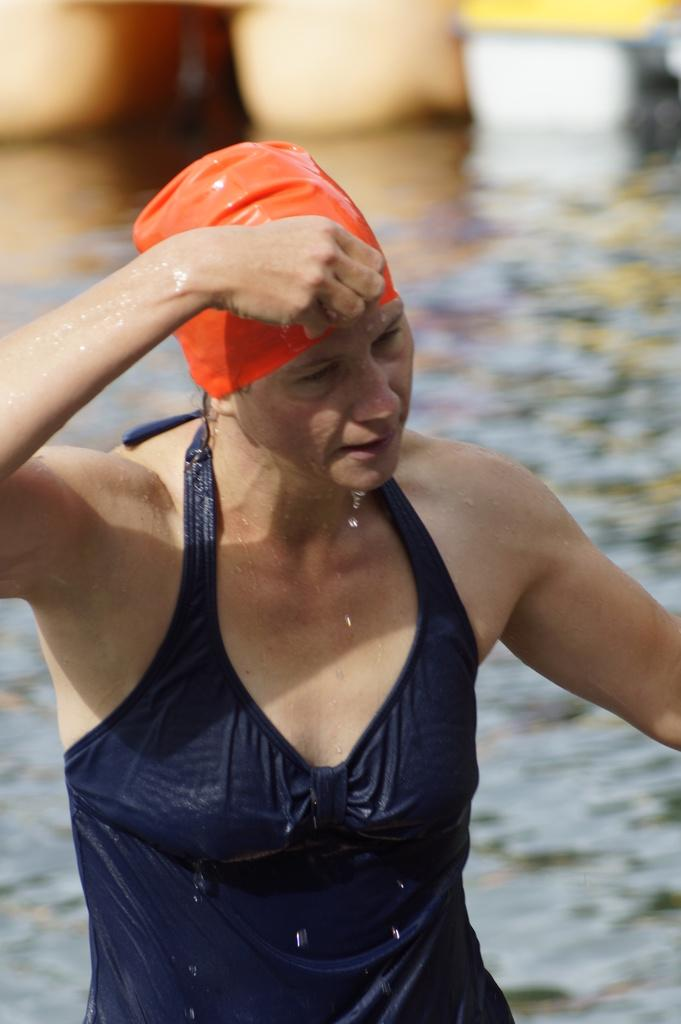Who is present in the image? There is a lady in the image. What is the lady doing in the image? The lady is standing in a water body. What is the lady wearing in the image? The lady is wearing a swimming suit and a cap. What can be seen in the background of the image? There is a water body and a person's legs visible in the background of the image. What type of turkey can be seen in the image? There is no turkey present in the image. How does the lady plan to take a trip while standing in the water body? The image does not provide any information about the lady planning a trip or any related activities. 